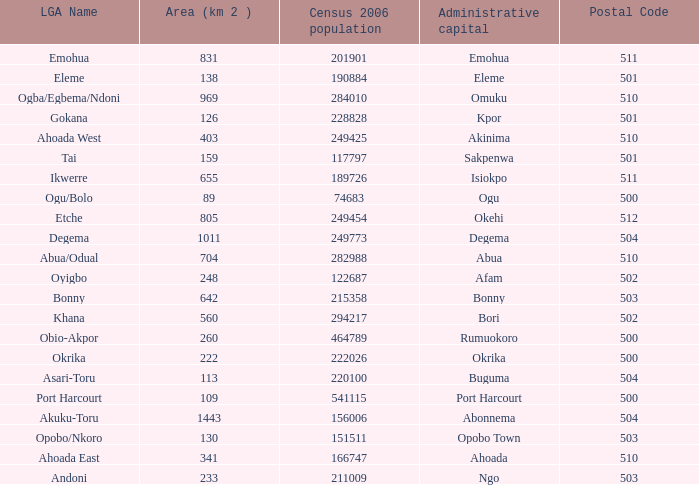What is the area when the Iga name is Ahoada East? 341.0. 